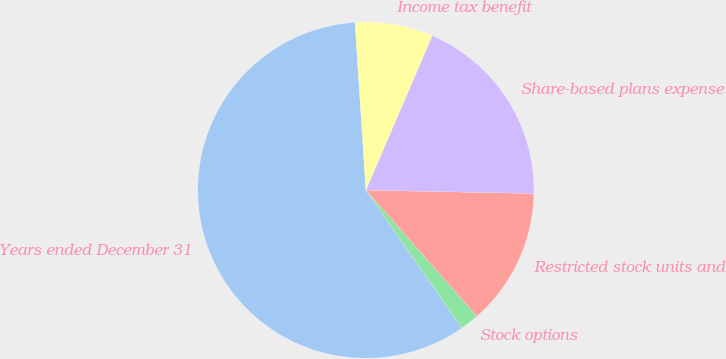Convert chart. <chart><loc_0><loc_0><loc_500><loc_500><pie_chart><fcel>Years ended December 31<fcel>Stock options<fcel>Restricted stock units and<fcel>Share-based plans expense<fcel>Income tax benefit<nl><fcel>58.66%<fcel>1.81%<fcel>13.18%<fcel>18.86%<fcel>7.49%<nl></chart> 